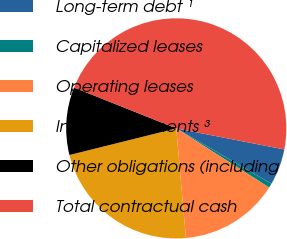Convert chart to OTSL. <chart><loc_0><loc_0><loc_500><loc_500><pie_chart><fcel>Long-term debt ¹<fcel>Capitalized leases<fcel>Operating leases<fcel>Interest payments ³<fcel>Other obligations (including<fcel>Total contractual cash<nl><fcel>5.3%<fcel>0.66%<fcel>14.57%<fcel>22.52%<fcel>9.93%<fcel>47.02%<nl></chart> 